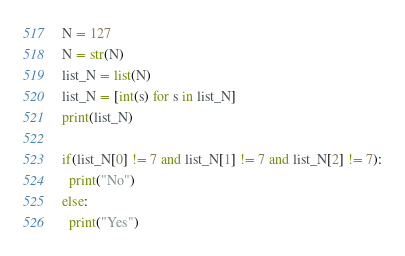Convert code to text. <code><loc_0><loc_0><loc_500><loc_500><_Python_>N = 127
N = str(N)
list_N = list(N)
list_N = [int(s) for s in list_N]
print(list_N)

if(list_N[0] != 7 and list_N[1] != 7 and list_N[2] != 7):
  print("No")
else:
  print("Yes")</code> 